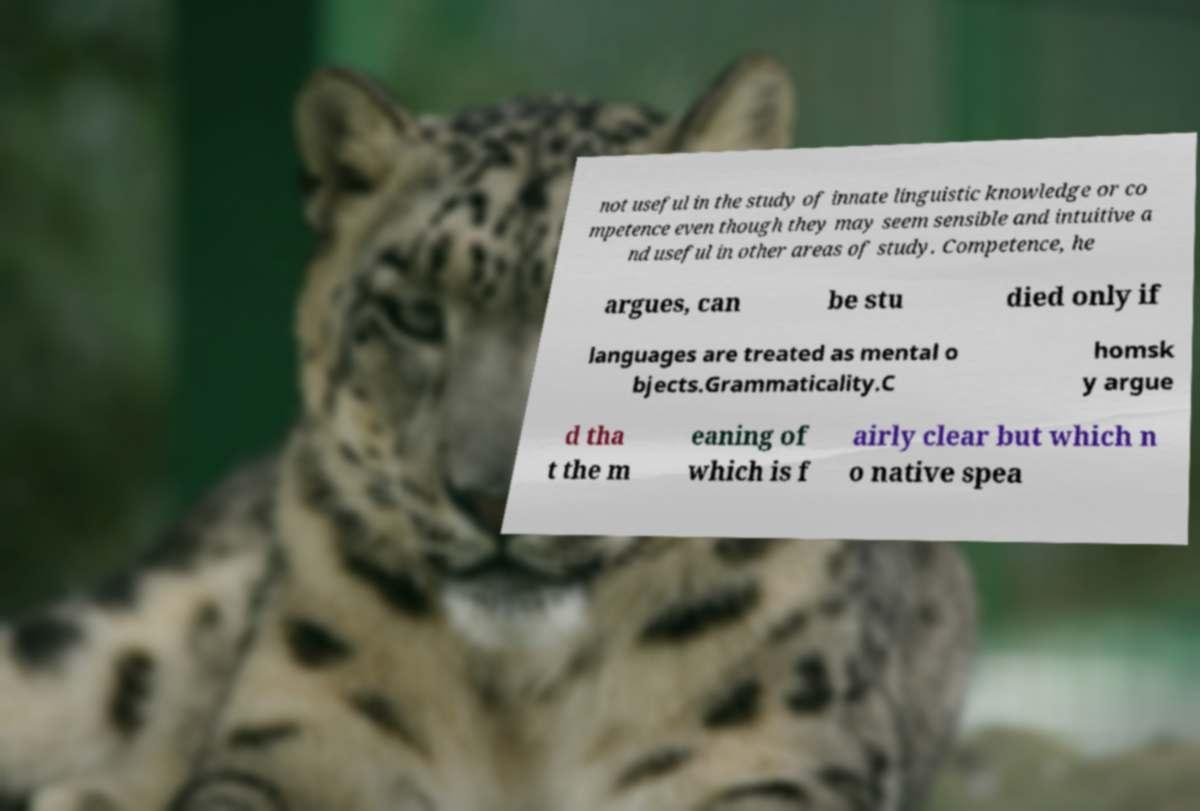Please identify and transcribe the text found in this image. not useful in the study of innate linguistic knowledge or co mpetence even though they may seem sensible and intuitive a nd useful in other areas of study. Competence, he argues, can be stu died only if languages are treated as mental o bjects.Grammaticality.C homsk y argue d tha t the m eaning of which is f airly clear but which n o native spea 